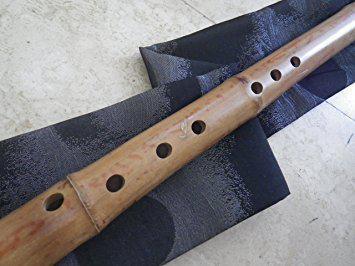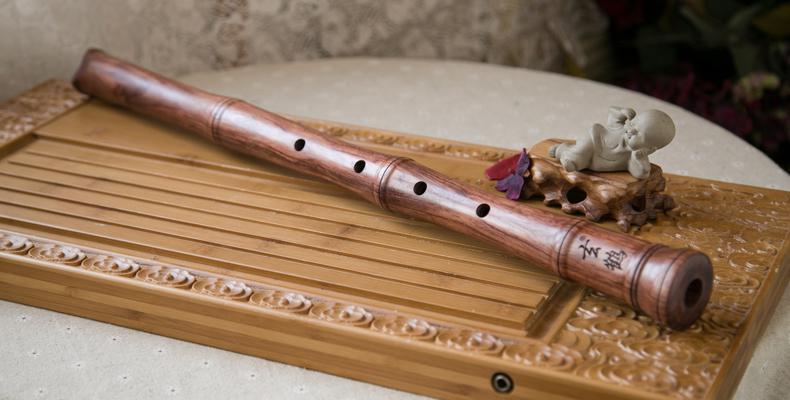The first image is the image on the left, the second image is the image on the right. Given the left and right images, does the statement "The left and right image contains the same number of flutes." hold true? Answer yes or no. Yes. The first image is the image on the left, the second image is the image on the right. Considering the images on both sides, is "Each image contains exactly one bamboo flute, and the left image shows a flute displayed diagonally and overlapping a folded band of cloth." valid? Answer yes or no. Yes. 